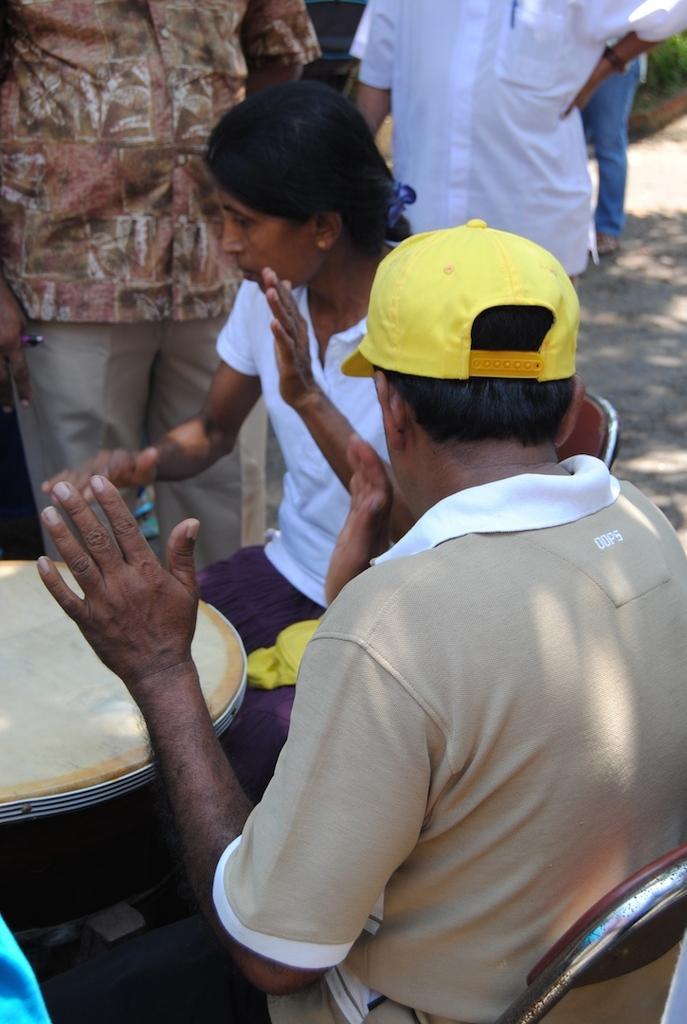Could you give a brief overview of what you see in this image? In this picture there are two people sitting and playing musical instrument. At the back there are three people standing and there is a plant. At the bottom there is ground. 